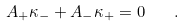<formula> <loc_0><loc_0><loc_500><loc_500>A _ { + } \kappa _ { - } + A _ { - } \kappa _ { + } = 0 \quad .</formula> 